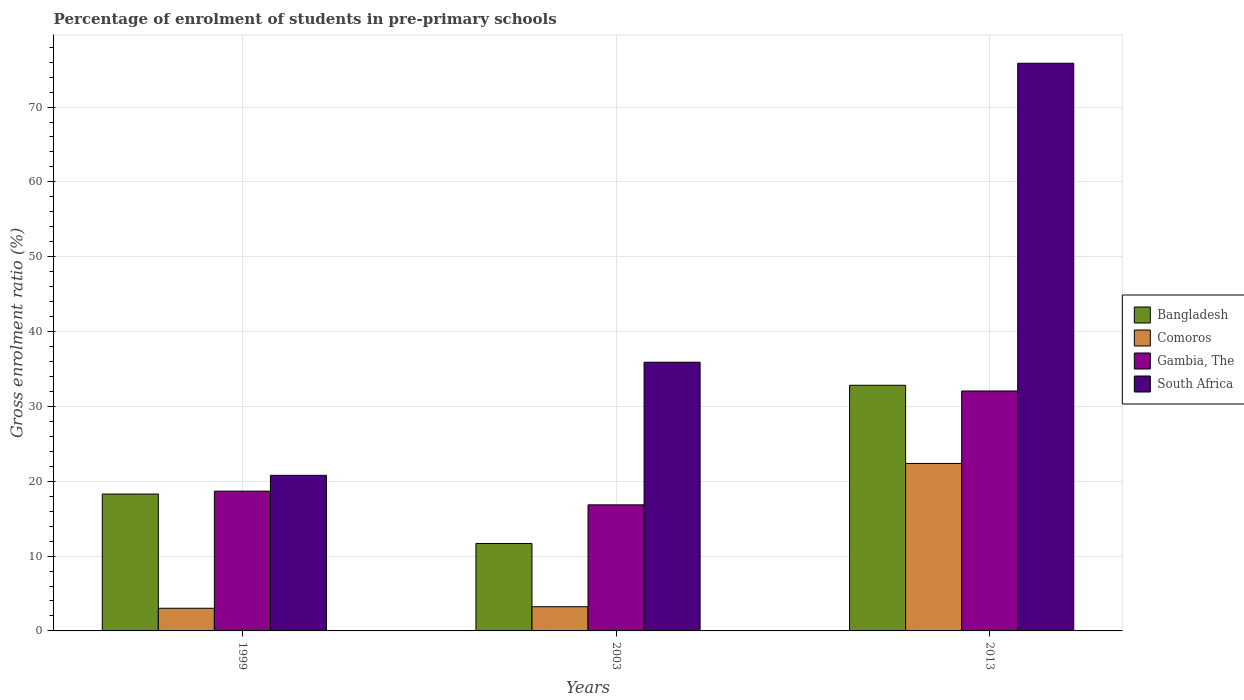How many different coloured bars are there?
Keep it short and to the point. 4. Are the number of bars per tick equal to the number of legend labels?
Ensure brevity in your answer.  Yes. What is the label of the 2nd group of bars from the left?
Your response must be concise. 2003. What is the percentage of students enrolled in pre-primary schools in Comoros in 1999?
Your answer should be very brief. 3.03. Across all years, what is the maximum percentage of students enrolled in pre-primary schools in Comoros?
Give a very brief answer. 22.38. Across all years, what is the minimum percentage of students enrolled in pre-primary schools in Gambia, The?
Provide a succinct answer. 16.85. What is the total percentage of students enrolled in pre-primary schools in Gambia, The in the graph?
Ensure brevity in your answer.  67.58. What is the difference between the percentage of students enrolled in pre-primary schools in Bangladesh in 1999 and that in 2003?
Ensure brevity in your answer.  6.6. What is the difference between the percentage of students enrolled in pre-primary schools in Gambia, The in 2013 and the percentage of students enrolled in pre-primary schools in Comoros in 1999?
Provide a short and direct response. 29.03. What is the average percentage of students enrolled in pre-primary schools in South Africa per year?
Your response must be concise. 44.18. In the year 2003, what is the difference between the percentage of students enrolled in pre-primary schools in Comoros and percentage of students enrolled in pre-primary schools in South Africa?
Keep it short and to the point. -32.67. In how many years, is the percentage of students enrolled in pre-primary schools in Bangladesh greater than 48 %?
Offer a very short reply. 0. What is the ratio of the percentage of students enrolled in pre-primary schools in Bangladesh in 1999 to that in 2003?
Keep it short and to the point. 1.57. Is the percentage of students enrolled in pre-primary schools in Bangladesh in 1999 less than that in 2013?
Your response must be concise. Yes. Is the difference between the percentage of students enrolled in pre-primary schools in Comoros in 1999 and 2013 greater than the difference between the percentage of students enrolled in pre-primary schools in South Africa in 1999 and 2013?
Your answer should be compact. Yes. What is the difference between the highest and the second highest percentage of students enrolled in pre-primary schools in Bangladesh?
Give a very brief answer. 14.53. What is the difference between the highest and the lowest percentage of students enrolled in pre-primary schools in South Africa?
Your response must be concise. 55.06. Is the sum of the percentage of students enrolled in pre-primary schools in Bangladesh in 1999 and 2013 greater than the maximum percentage of students enrolled in pre-primary schools in Comoros across all years?
Your answer should be compact. Yes. What does the 3rd bar from the left in 1999 represents?
Provide a short and direct response. Gambia, The. What does the 2nd bar from the right in 2003 represents?
Make the answer very short. Gambia, The. How many bars are there?
Offer a terse response. 12. Are all the bars in the graph horizontal?
Keep it short and to the point. No. What is the difference between two consecutive major ticks on the Y-axis?
Offer a very short reply. 10. Are the values on the major ticks of Y-axis written in scientific E-notation?
Ensure brevity in your answer.  No. Does the graph contain grids?
Give a very brief answer. Yes. Where does the legend appear in the graph?
Offer a very short reply. Center right. How are the legend labels stacked?
Your answer should be compact. Vertical. What is the title of the graph?
Your answer should be compact. Percentage of enrolment of students in pre-primary schools. What is the label or title of the Y-axis?
Offer a very short reply. Gross enrolment ratio (%). What is the Gross enrolment ratio (%) in Bangladesh in 1999?
Offer a terse response. 18.29. What is the Gross enrolment ratio (%) of Comoros in 1999?
Provide a short and direct response. 3.03. What is the Gross enrolment ratio (%) of Gambia, The in 1999?
Provide a succinct answer. 18.68. What is the Gross enrolment ratio (%) in South Africa in 1999?
Keep it short and to the point. 20.79. What is the Gross enrolment ratio (%) of Bangladesh in 2003?
Provide a succinct answer. 11.68. What is the Gross enrolment ratio (%) in Comoros in 2003?
Your answer should be compact. 3.23. What is the Gross enrolment ratio (%) in Gambia, The in 2003?
Your response must be concise. 16.85. What is the Gross enrolment ratio (%) of South Africa in 2003?
Provide a succinct answer. 35.9. What is the Gross enrolment ratio (%) in Bangladesh in 2013?
Make the answer very short. 32.82. What is the Gross enrolment ratio (%) of Comoros in 2013?
Keep it short and to the point. 22.38. What is the Gross enrolment ratio (%) in Gambia, The in 2013?
Keep it short and to the point. 32.06. What is the Gross enrolment ratio (%) in South Africa in 2013?
Provide a succinct answer. 75.85. Across all years, what is the maximum Gross enrolment ratio (%) in Bangladesh?
Your answer should be very brief. 32.82. Across all years, what is the maximum Gross enrolment ratio (%) of Comoros?
Your answer should be compact. 22.38. Across all years, what is the maximum Gross enrolment ratio (%) in Gambia, The?
Offer a terse response. 32.06. Across all years, what is the maximum Gross enrolment ratio (%) of South Africa?
Your answer should be compact. 75.85. Across all years, what is the minimum Gross enrolment ratio (%) of Bangladesh?
Offer a terse response. 11.68. Across all years, what is the minimum Gross enrolment ratio (%) of Comoros?
Offer a terse response. 3.03. Across all years, what is the minimum Gross enrolment ratio (%) in Gambia, The?
Ensure brevity in your answer.  16.85. Across all years, what is the minimum Gross enrolment ratio (%) in South Africa?
Your answer should be compact. 20.79. What is the total Gross enrolment ratio (%) of Bangladesh in the graph?
Give a very brief answer. 62.8. What is the total Gross enrolment ratio (%) of Comoros in the graph?
Keep it short and to the point. 28.64. What is the total Gross enrolment ratio (%) of Gambia, The in the graph?
Provide a short and direct response. 67.58. What is the total Gross enrolment ratio (%) of South Africa in the graph?
Provide a succinct answer. 132.54. What is the difference between the Gross enrolment ratio (%) of Bangladesh in 1999 and that in 2003?
Your answer should be compact. 6.6. What is the difference between the Gross enrolment ratio (%) in Comoros in 1999 and that in 2003?
Provide a short and direct response. -0.2. What is the difference between the Gross enrolment ratio (%) in Gambia, The in 1999 and that in 2003?
Provide a short and direct response. 1.83. What is the difference between the Gross enrolment ratio (%) in South Africa in 1999 and that in 2003?
Ensure brevity in your answer.  -15.11. What is the difference between the Gross enrolment ratio (%) of Bangladesh in 1999 and that in 2013?
Make the answer very short. -14.53. What is the difference between the Gross enrolment ratio (%) of Comoros in 1999 and that in 2013?
Provide a succinct answer. -19.35. What is the difference between the Gross enrolment ratio (%) in Gambia, The in 1999 and that in 2013?
Give a very brief answer. -13.38. What is the difference between the Gross enrolment ratio (%) in South Africa in 1999 and that in 2013?
Offer a very short reply. -55.06. What is the difference between the Gross enrolment ratio (%) in Bangladesh in 2003 and that in 2013?
Offer a terse response. -21.14. What is the difference between the Gross enrolment ratio (%) of Comoros in 2003 and that in 2013?
Your response must be concise. -19.15. What is the difference between the Gross enrolment ratio (%) of Gambia, The in 2003 and that in 2013?
Offer a terse response. -15.21. What is the difference between the Gross enrolment ratio (%) in South Africa in 2003 and that in 2013?
Your answer should be very brief. -39.95. What is the difference between the Gross enrolment ratio (%) in Bangladesh in 1999 and the Gross enrolment ratio (%) in Comoros in 2003?
Your answer should be compact. 15.06. What is the difference between the Gross enrolment ratio (%) in Bangladesh in 1999 and the Gross enrolment ratio (%) in Gambia, The in 2003?
Offer a terse response. 1.44. What is the difference between the Gross enrolment ratio (%) in Bangladesh in 1999 and the Gross enrolment ratio (%) in South Africa in 2003?
Your answer should be very brief. -17.61. What is the difference between the Gross enrolment ratio (%) in Comoros in 1999 and the Gross enrolment ratio (%) in Gambia, The in 2003?
Give a very brief answer. -13.82. What is the difference between the Gross enrolment ratio (%) of Comoros in 1999 and the Gross enrolment ratio (%) of South Africa in 2003?
Provide a short and direct response. -32.87. What is the difference between the Gross enrolment ratio (%) of Gambia, The in 1999 and the Gross enrolment ratio (%) of South Africa in 2003?
Your response must be concise. -17.23. What is the difference between the Gross enrolment ratio (%) of Bangladesh in 1999 and the Gross enrolment ratio (%) of Comoros in 2013?
Keep it short and to the point. -4.09. What is the difference between the Gross enrolment ratio (%) in Bangladesh in 1999 and the Gross enrolment ratio (%) in Gambia, The in 2013?
Provide a short and direct response. -13.77. What is the difference between the Gross enrolment ratio (%) of Bangladesh in 1999 and the Gross enrolment ratio (%) of South Africa in 2013?
Offer a terse response. -57.56. What is the difference between the Gross enrolment ratio (%) in Comoros in 1999 and the Gross enrolment ratio (%) in Gambia, The in 2013?
Provide a short and direct response. -29.03. What is the difference between the Gross enrolment ratio (%) in Comoros in 1999 and the Gross enrolment ratio (%) in South Africa in 2013?
Provide a short and direct response. -72.82. What is the difference between the Gross enrolment ratio (%) of Gambia, The in 1999 and the Gross enrolment ratio (%) of South Africa in 2013?
Keep it short and to the point. -57.17. What is the difference between the Gross enrolment ratio (%) in Bangladesh in 2003 and the Gross enrolment ratio (%) in Comoros in 2013?
Make the answer very short. -10.69. What is the difference between the Gross enrolment ratio (%) in Bangladesh in 2003 and the Gross enrolment ratio (%) in Gambia, The in 2013?
Provide a short and direct response. -20.37. What is the difference between the Gross enrolment ratio (%) of Bangladesh in 2003 and the Gross enrolment ratio (%) of South Africa in 2013?
Make the answer very short. -64.16. What is the difference between the Gross enrolment ratio (%) of Comoros in 2003 and the Gross enrolment ratio (%) of Gambia, The in 2013?
Give a very brief answer. -28.83. What is the difference between the Gross enrolment ratio (%) in Comoros in 2003 and the Gross enrolment ratio (%) in South Africa in 2013?
Keep it short and to the point. -72.62. What is the difference between the Gross enrolment ratio (%) of Gambia, The in 2003 and the Gross enrolment ratio (%) of South Africa in 2013?
Your answer should be compact. -59. What is the average Gross enrolment ratio (%) in Bangladesh per year?
Offer a terse response. 20.93. What is the average Gross enrolment ratio (%) in Comoros per year?
Offer a terse response. 9.55. What is the average Gross enrolment ratio (%) in Gambia, The per year?
Provide a short and direct response. 22.53. What is the average Gross enrolment ratio (%) of South Africa per year?
Your answer should be very brief. 44.18. In the year 1999, what is the difference between the Gross enrolment ratio (%) in Bangladesh and Gross enrolment ratio (%) in Comoros?
Your response must be concise. 15.26. In the year 1999, what is the difference between the Gross enrolment ratio (%) in Bangladesh and Gross enrolment ratio (%) in Gambia, The?
Give a very brief answer. -0.39. In the year 1999, what is the difference between the Gross enrolment ratio (%) in Bangladesh and Gross enrolment ratio (%) in South Africa?
Give a very brief answer. -2.5. In the year 1999, what is the difference between the Gross enrolment ratio (%) in Comoros and Gross enrolment ratio (%) in Gambia, The?
Your response must be concise. -15.65. In the year 1999, what is the difference between the Gross enrolment ratio (%) of Comoros and Gross enrolment ratio (%) of South Africa?
Ensure brevity in your answer.  -17.76. In the year 1999, what is the difference between the Gross enrolment ratio (%) in Gambia, The and Gross enrolment ratio (%) in South Africa?
Provide a succinct answer. -2.11. In the year 2003, what is the difference between the Gross enrolment ratio (%) in Bangladesh and Gross enrolment ratio (%) in Comoros?
Offer a very short reply. 8.45. In the year 2003, what is the difference between the Gross enrolment ratio (%) in Bangladesh and Gross enrolment ratio (%) in Gambia, The?
Give a very brief answer. -5.16. In the year 2003, what is the difference between the Gross enrolment ratio (%) of Bangladesh and Gross enrolment ratio (%) of South Africa?
Offer a terse response. -24.22. In the year 2003, what is the difference between the Gross enrolment ratio (%) in Comoros and Gross enrolment ratio (%) in Gambia, The?
Your response must be concise. -13.62. In the year 2003, what is the difference between the Gross enrolment ratio (%) of Comoros and Gross enrolment ratio (%) of South Africa?
Give a very brief answer. -32.67. In the year 2003, what is the difference between the Gross enrolment ratio (%) of Gambia, The and Gross enrolment ratio (%) of South Africa?
Provide a short and direct response. -19.05. In the year 2013, what is the difference between the Gross enrolment ratio (%) of Bangladesh and Gross enrolment ratio (%) of Comoros?
Your response must be concise. 10.44. In the year 2013, what is the difference between the Gross enrolment ratio (%) in Bangladesh and Gross enrolment ratio (%) in Gambia, The?
Provide a succinct answer. 0.76. In the year 2013, what is the difference between the Gross enrolment ratio (%) in Bangladesh and Gross enrolment ratio (%) in South Africa?
Keep it short and to the point. -43.03. In the year 2013, what is the difference between the Gross enrolment ratio (%) in Comoros and Gross enrolment ratio (%) in Gambia, The?
Offer a terse response. -9.68. In the year 2013, what is the difference between the Gross enrolment ratio (%) of Comoros and Gross enrolment ratio (%) of South Africa?
Make the answer very short. -53.47. In the year 2013, what is the difference between the Gross enrolment ratio (%) of Gambia, The and Gross enrolment ratio (%) of South Africa?
Your answer should be very brief. -43.79. What is the ratio of the Gross enrolment ratio (%) of Bangladesh in 1999 to that in 2003?
Give a very brief answer. 1.57. What is the ratio of the Gross enrolment ratio (%) in Comoros in 1999 to that in 2003?
Give a very brief answer. 0.94. What is the ratio of the Gross enrolment ratio (%) in Gambia, The in 1999 to that in 2003?
Provide a succinct answer. 1.11. What is the ratio of the Gross enrolment ratio (%) of South Africa in 1999 to that in 2003?
Your answer should be very brief. 0.58. What is the ratio of the Gross enrolment ratio (%) of Bangladesh in 1999 to that in 2013?
Offer a terse response. 0.56. What is the ratio of the Gross enrolment ratio (%) of Comoros in 1999 to that in 2013?
Your answer should be compact. 0.14. What is the ratio of the Gross enrolment ratio (%) in Gambia, The in 1999 to that in 2013?
Your response must be concise. 0.58. What is the ratio of the Gross enrolment ratio (%) in South Africa in 1999 to that in 2013?
Provide a succinct answer. 0.27. What is the ratio of the Gross enrolment ratio (%) of Bangladesh in 2003 to that in 2013?
Your response must be concise. 0.36. What is the ratio of the Gross enrolment ratio (%) of Comoros in 2003 to that in 2013?
Your answer should be very brief. 0.14. What is the ratio of the Gross enrolment ratio (%) of Gambia, The in 2003 to that in 2013?
Give a very brief answer. 0.53. What is the ratio of the Gross enrolment ratio (%) of South Africa in 2003 to that in 2013?
Ensure brevity in your answer.  0.47. What is the difference between the highest and the second highest Gross enrolment ratio (%) of Bangladesh?
Your answer should be very brief. 14.53. What is the difference between the highest and the second highest Gross enrolment ratio (%) of Comoros?
Give a very brief answer. 19.15. What is the difference between the highest and the second highest Gross enrolment ratio (%) in Gambia, The?
Provide a succinct answer. 13.38. What is the difference between the highest and the second highest Gross enrolment ratio (%) in South Africa?
Make the answer very short. 39.95. What is the difference between the highest and the lowest Gross enrolment ratio (%) of Bangladesh?
Ensure brevity in your answer.  21.14. What is the difference between the highest and the lowest Gross enrolment ratio (%) in Comoros?
Ensure brevity in your answer.  19.35. What is the difference between the highest and the lowest Gross enrolment ratio (%) of Gambia, The?
Provide a short and direct response. 15.21. What is the difference between the highest and the lowest Gross enrolment ratio (%) of South Africa?
Your response must be concise. 55.06. 